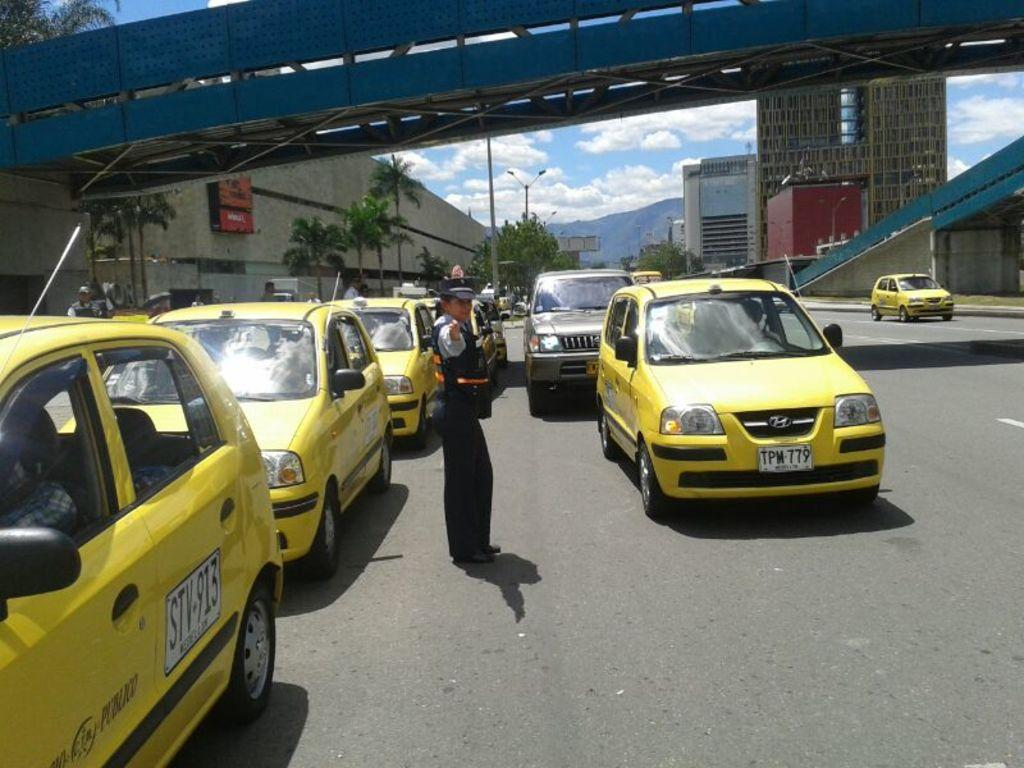<image>
Render a clear and concise summary of the photo. Woman directing traffic of different taxi cabs on the street, one of the cars has license plate: TPM-779. 